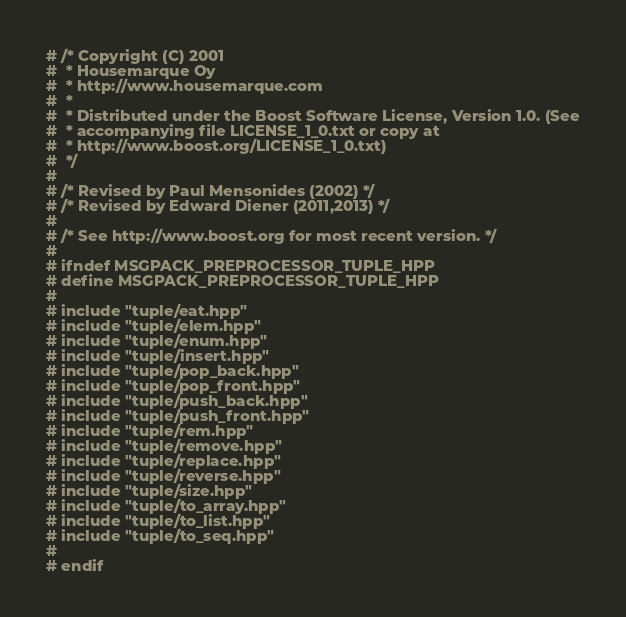Convert code to text. <code><loc_0><loc_0><loc_500><loc_500><_C++_># /* Copyright (C) 2001
#  * Housemarque Oy
#  * http://www.housemarque.com
#  *
#  * Distributed under the Boost Software License, Version 1.0. (See
#  * accompanying file LICENSE_1_0.txt or copy at
#  * http://www.boost.org/LICENSE_1_0.txt)
#  */
#
# /* Revised by Paul Mensonides (2002) */
# /* Revised by Edward Diener (2011,2013) */
#
# /* See http://www.boost.org for most recent version. */
#
# ifndef MSGPACK_PREPROCESSOR_TUPLE_HPP
# define MSGPACK_PREPROCESSOR_TUPLE_HPP
#
# include "tuple/eat.hpp"
# include "tuple/elem.hpp"
# include "tuple/enum.hpp"
# include "tuple/insert.hpp"
# include "tuple/pop_back.hpp"
# include "tuple/pop_front.hpp"
# include "tuple/push_back.hpp"
# include "tuple/push_front.hpp"
# include "tuple/rem.hpp"
# include "tuple/remove.hpp"
# include "tuple/replace.hpp"
# include "tuple/reverse.hpp"
# include "tuple/size.hpp"
# include "tuple/to_array.hpp"
# include "tuple/to_list.hpp"
# include "tuple/to_seq.hpp"
#
# endif
</code> 